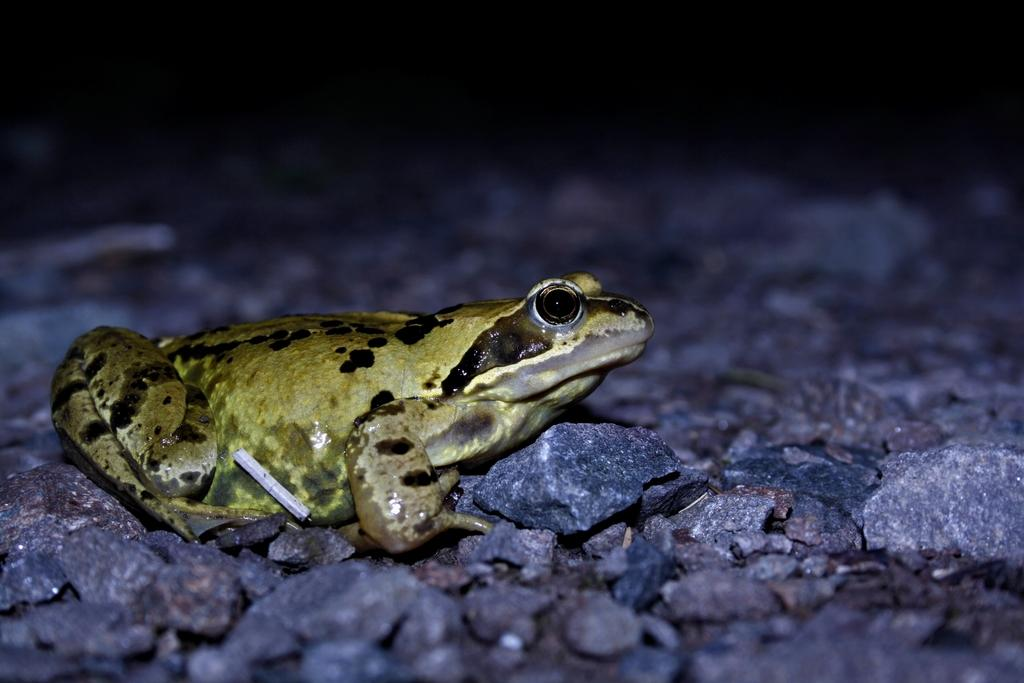What type of animal is in the image? There is a frog in the image. Where is the frog located? The frog is on the surface of rocks. What type of reward does the grandmother give to the frog in the image? There is no grandmother or reward present in the image; it only features a frog on rocks. 